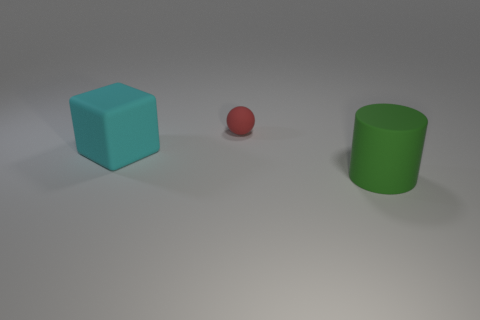Could you describe the surface the objects are resting on? The objects are resting on a smooth, flat surface that appears to be matte in texture, which absorbs the light rather than reflecting it. This suggests it might be some kind of non-reflective material, providing a clear view of the items without distraction from glossy reflections. 